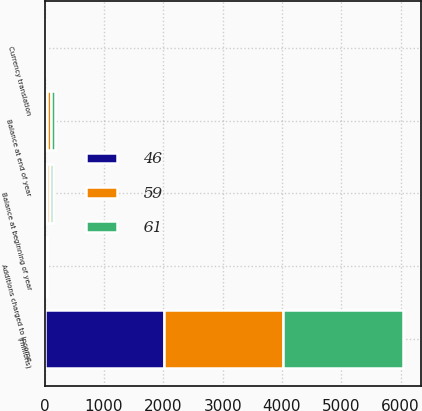Convert chart to OTSL. <chart><loc_0><loc_0><loc_500><loc_500><stacked_bar_chart><ecel><fcel>(millions)<fcel>Balance at beginning of year<fcel>Additions charged to income<fcel>Currency translation<fcel>Balance at end of year<nl><fcel>59<fcel>2013<fcel>59<fcel>17<fcel>2<fcel>61<nl><fcel>61<fcel>2012<fcel>46<fcel>12<fcel>1<fcel>59<nl><fcel>46<fcel>2011<fcel>36<fcel>12<fcel>1<fcel>46<nl></chart> 